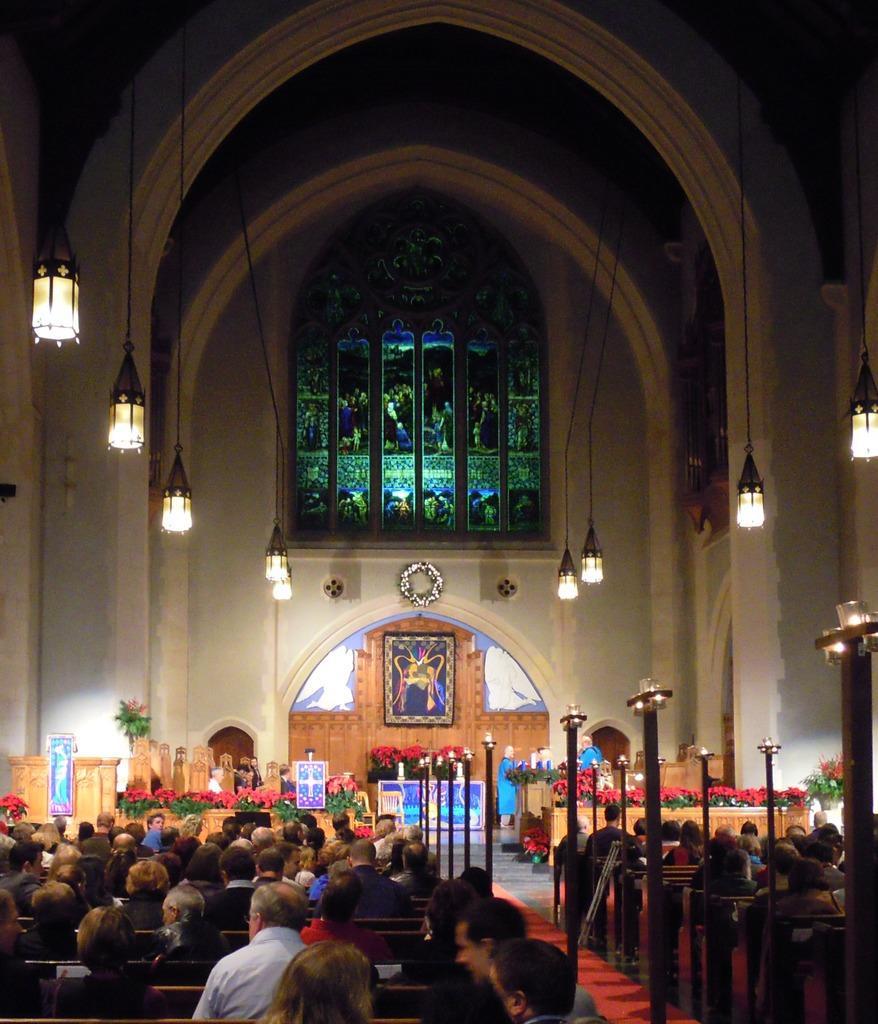Could you give a brief overview of what you see in this image? In this picture we can see some people are sitting in the front, there are some lights in the middle, in the background there are some flowers and a photo frame. 